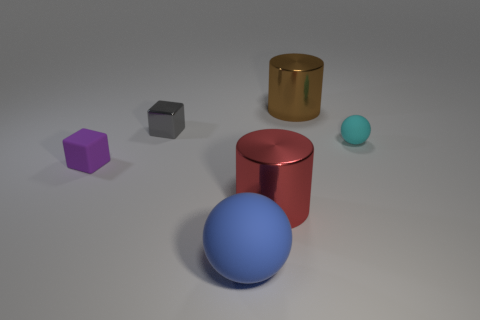How many spheres are tiny yellow rubber objects or tiny gray shiny objects?
Ensure brevity in your answer.  0. How many things are both to the left of the tiny matte ball and behind the small purple matte block?
Offer a very short reply. 2. There is a matte object that is left of the blue ball; what is its color?
Give a very brief answer. Purple. There is a sphere that is the same material as the small cyan object; what size is it?
Your answer should be compact. Large. What number of small purple matte objects are to the left of the small block behind the tiny rubber ball?
Offer a very short reply. 1. What number of tiny objects are behind the blue matte thing?
Keep it short and to the point. 3. What is the color of the sphere right of the big cylinder that is behind the small thing behind the cyan rubber object?
Offer a very short reply. Cyan. There is a matte ball that is behind the blue ball; is its color the same as the small matte object that is left of the large ball?
Provide a succinct answer. No. What is the shape of the small rubber object to the right of the purple rubber cube that is behind the blue matte sphere?
Offer a terse response. Sphere. Is there a blue matte ball of the same size as the gray metal cube?
Offer a terse response. No. 